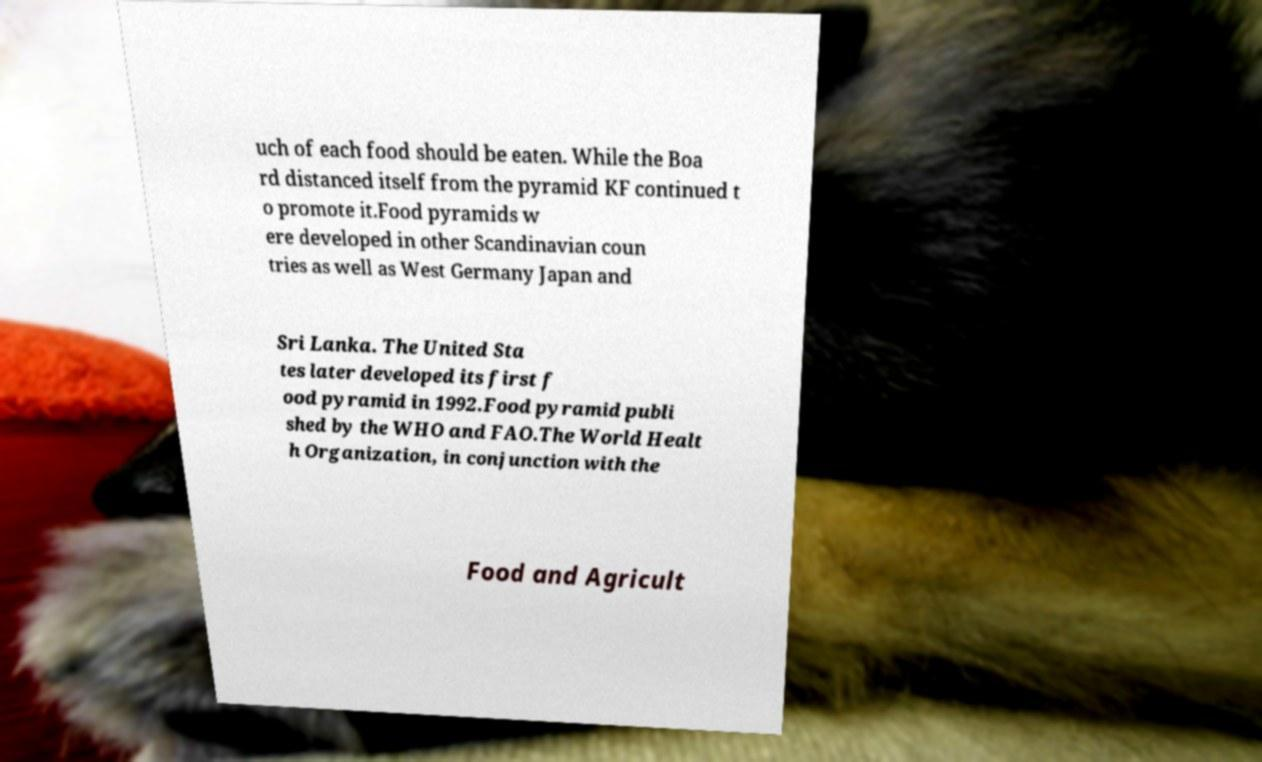For documentation purposes, I need the text within this image transcribed. Could you provide that? uch of each food should be eaten. While the Boa rd distanced itself from the pyramid KF continued t o promote it.Food pyramids w ere developed in other Scandinavian coun tries as well as West Germany Japan and Sri Lanka. The United Sta tes later developed its first f ood pyramid in 1992.Food pyramid publi shed by the WHO and FAO.The World Healt h Organization, in conjunction with the Food and Agricult 